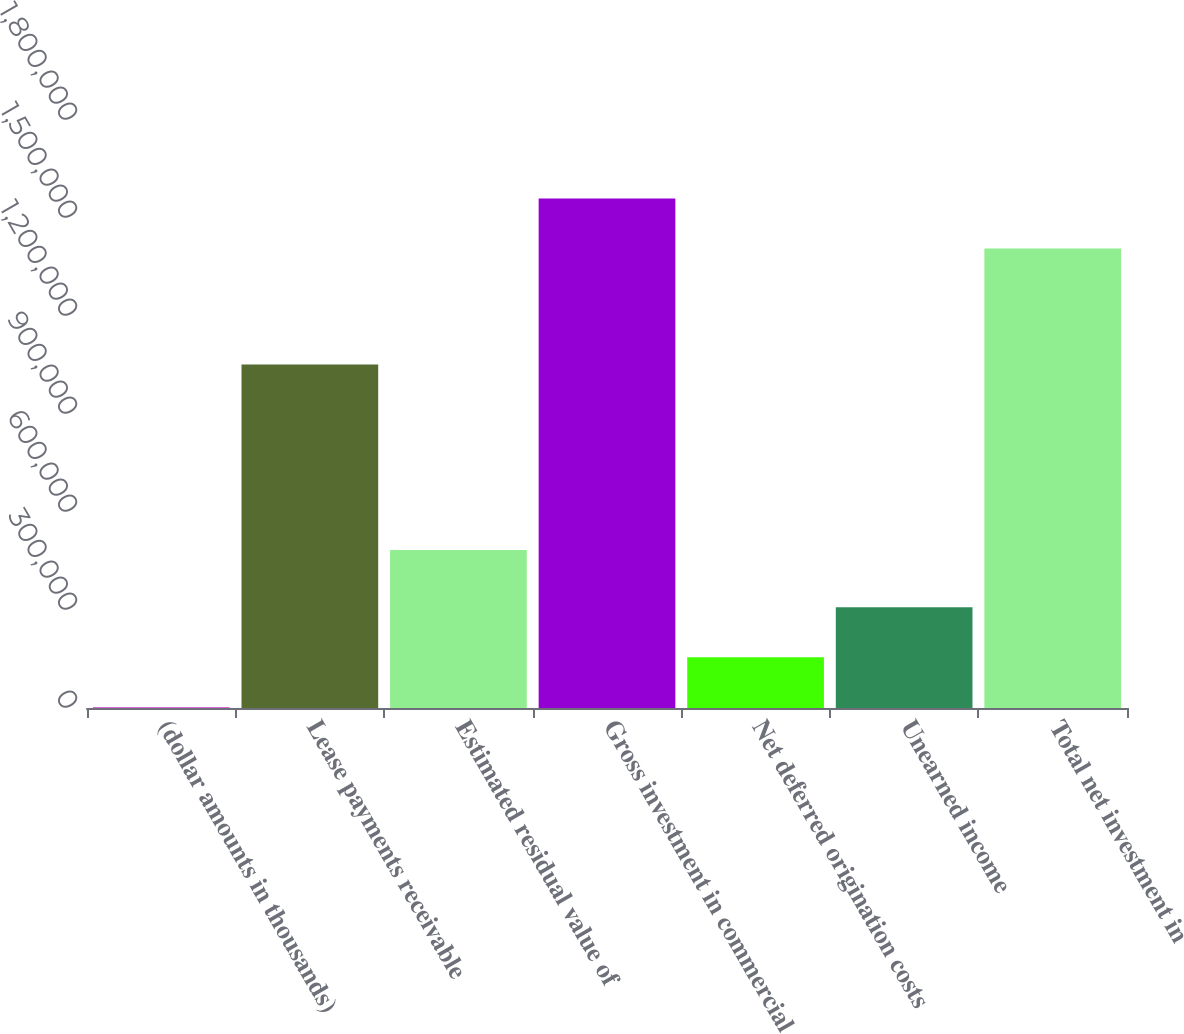<chart> <loc_0><loc_0><loc_500><loc_500><bar_chart><fcel>(dollar amounts in thousands)<fcel>Lease payments receivable<fcel>Estimated residual value of<fcel>Gross investment in commercial<fcel>Net deferred origination costs<fcel>Unearned income<fcel>Total net investment in<nl><fcel>2014<fcel>1.05174e+06<fcel>483407<fcel>1.55999e+06<fcel>155328<fcel>308641<fcel>1.40668e+06<nl></chart> 